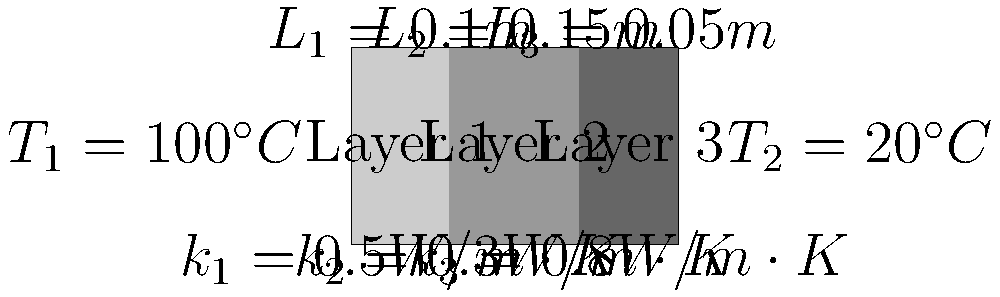Greetings, fellow Martian! Earthlings have created this fascinating technology called a "composite wall" to control heat flow. Given the wall structure and properties shown in the image, calculate the total heat transfer rate per unit area (heat flux) through this composite wall. Assume steady-state conditions and one-dimensional heat transfer. Express your answer in W/m². Oh, and remember to use your Earth units! Let's unravel this Earthling puzzle step by step:

1) For steady-state heat transfer through a composite wall, we use the concept of thermal resistance in series. The total thermal resistance is the sum of individual layer resistances.

2) The thermal resistance for each layer is given by:
   $R_i = \frac{L_i}{k_i}$

3) Calculate the thermal resistance for each layer:
   $R_1 = \frac{0.1}{0.5} = 0.2 \, m^2K/W$
   $R_2 = \frac{0.15}{0.3} = 0.5 \, m^2K/W$
   $R_3 = \frac{0.05}{0.8} = 0.0625 \, m^2K/W$

4) Total thermal resistance:
   $R_{total} = R_1 + R_2 + R_3 = 0.2 + 0.5 + 0.0625 = 0.7625 \, m^2K/W$

5) The heat flux is given by:
   $q = \frac{T_1 - T_2}{R_{total}}$

6) Plug in the values:
   $q = \frac{100^\circ C - 20^\circ C}{0.7625 \, m^2K/W} = \frac{80}{0.7625} = 104.92 \, W/m^2$

Therefore, the heat flux through the composite wall is approximately 104.92 W/m².
Answer: 104.92 W/m² 